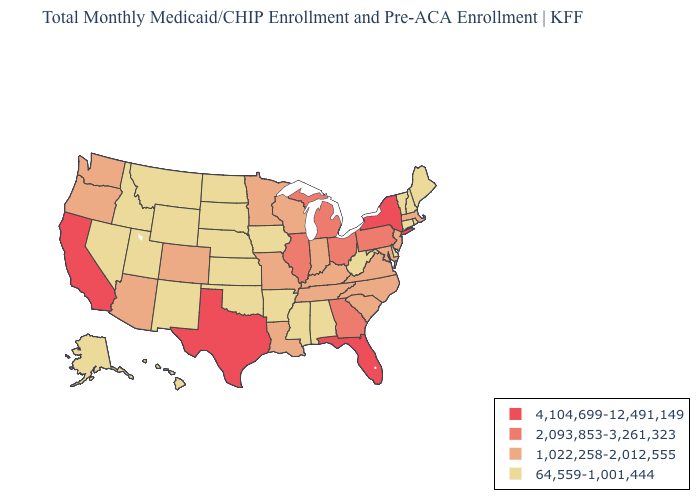Does New Hampshire have the lowest value in the Northeast?
Give a very brief answer. Yes. Does the map have missing data?
Quick response, please. No. Name the states that have a value in the range 2,093,853-3,261,323?
Write a very short answer. Georgia, Illinois, Michigan, Ohio, Pennsylvania. Does Michigan have the highest value in the MidWest?
Concise answer only. Yes. What is the value of Alabama?
Give a very brief answer. 64,559-1,001,444. Which states have the highest value in the USA?
Concise answer only. California, Florida, New York, Texas. Does the map have missing data?
Give a very brief answer. No. Does Oregon have a lower value than Maryland?
Write a very short answer. No. Among the states that border Minnesota , does Wisconsin have the highest value?
Quick response, please. Yes. Among the states that border New York , which have the lowest value?
Keep it brief. Connecticut, Vermont. What is the value of Oregon?
Keep it brief. 1,022,258-2,012,555. What is the value of Washington?
Short answer required. 1,022,258-2,012,555. Which states hav the highest value in the West?
Give a very brief answer. California. How many symbols are there in the legend?
Give a very brief answer. 4. Does Minnesota have the highest value in the MidWest?
Be succinct. No. 